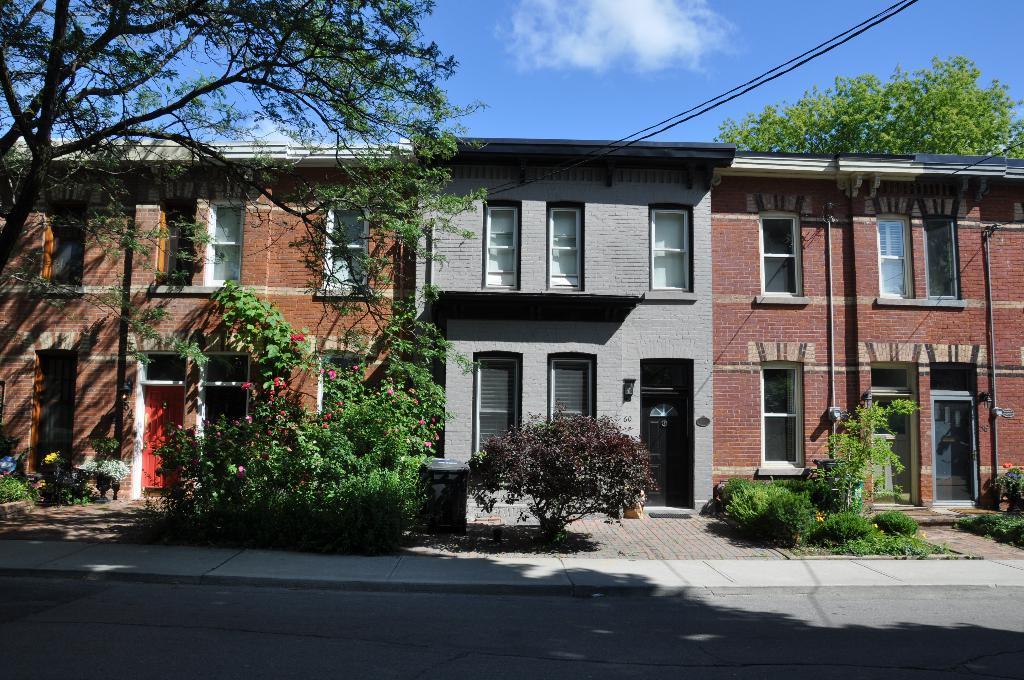Could you give a brief overview of what you see in this image? In this image I can see the road. To the side of the road there are plants and trees. In the background I can see the buildings and windows to it. I can also see the clouds and sky in the back. 